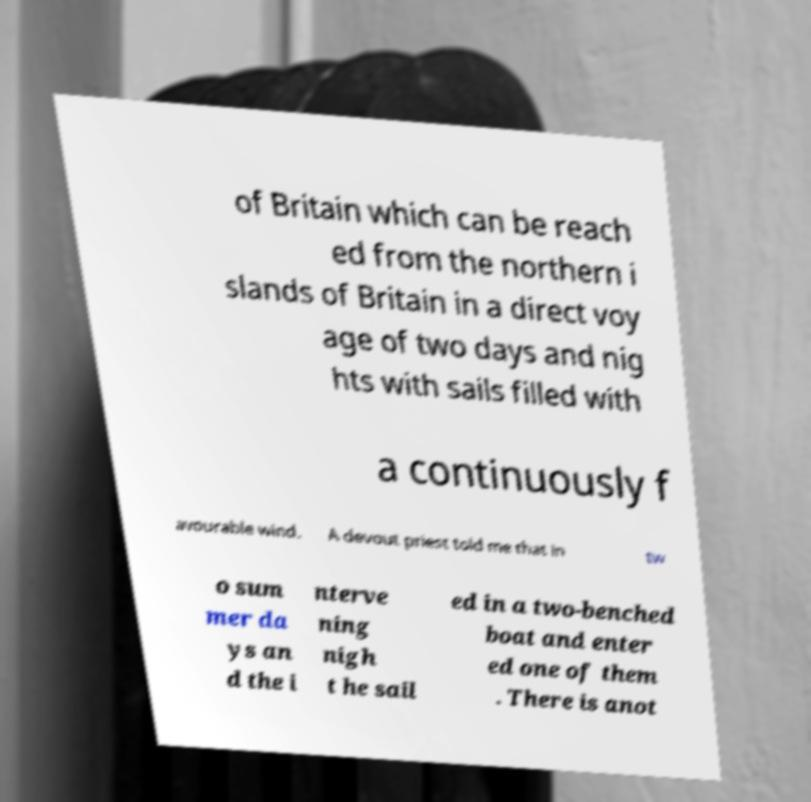Please identify and transcribe the text found in this image. of Britain which can be reach ed from the northern i slands of Britain in a direct voy age of two days and nig hts with sails filled with a continuously f avourable wind. A devout priest told me that in tw o sum mer da ys an d the i nterve ning nigh t he sail ed in a two-benched boat and enter ed one of them . There is anot 